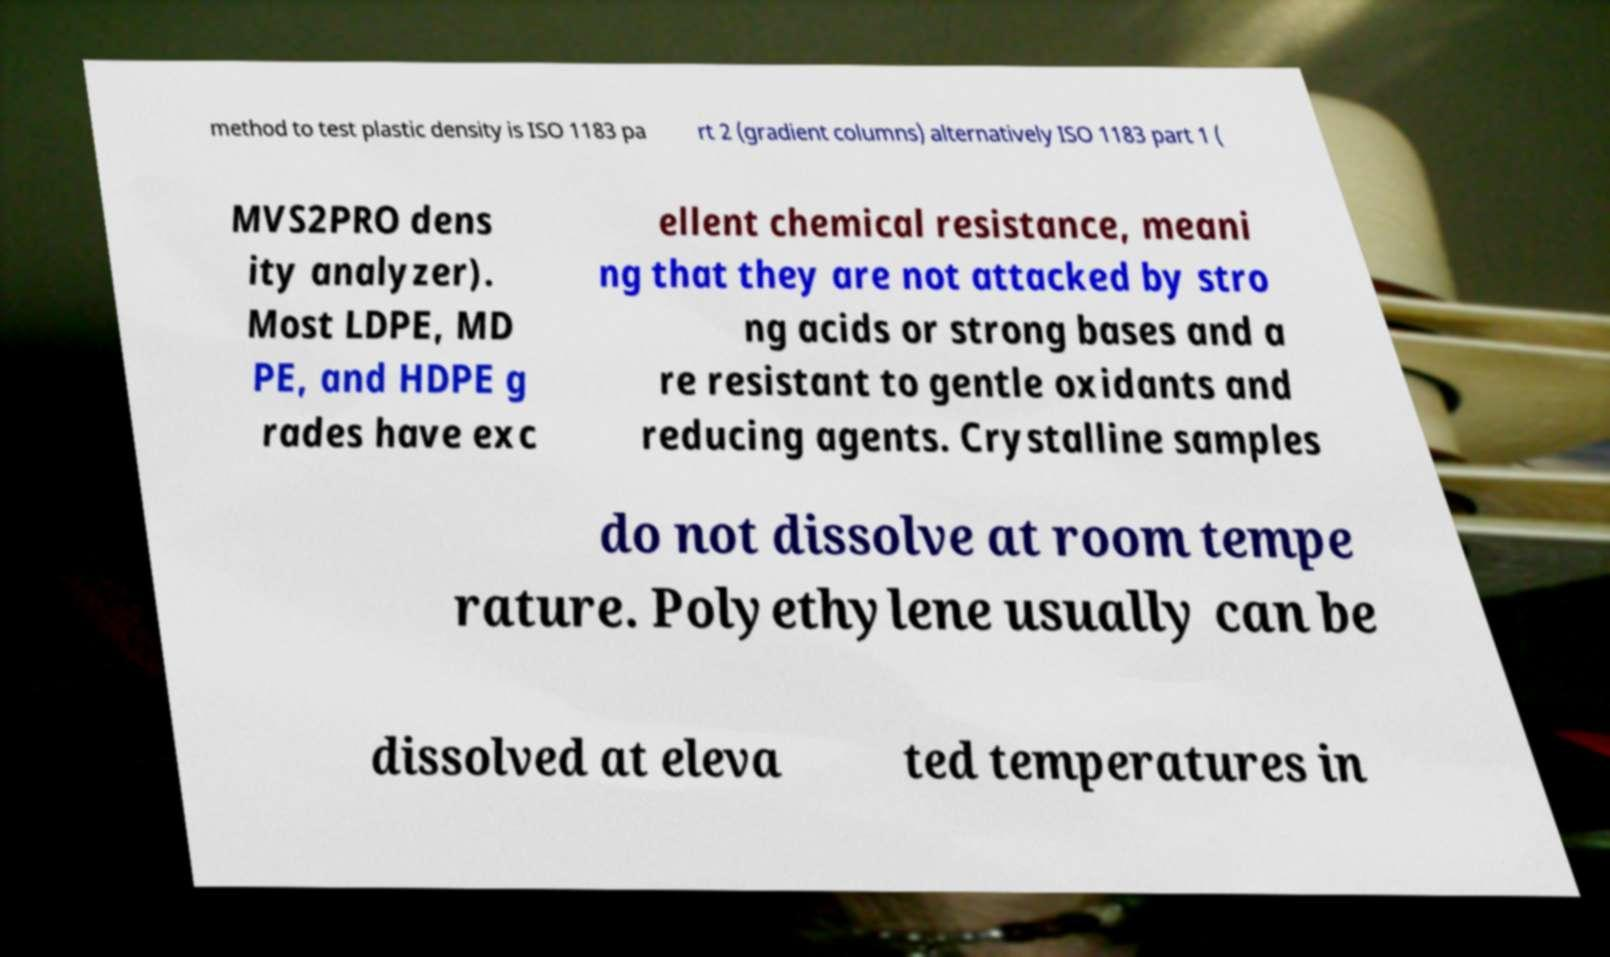What messages or text are displayed in this image? I need them in a readable, typed format. method to test plastic density is ISO 1183 pa rt 2 (gradient columns) alternatively ISO 1183 part 1 ( MVS2PRO dens ity analyzer). Most LDPE, MD PE, and HDPE g rades have exc ellent chemical resistance, meani ng that they are not attacked by stro ng acids or strong bases and a re resistant to gentle oxidants and reducing agents. Crystalline samples do not dissolve at room tempe rature. Polyethylene usually can be dissolved at eleva ted temperatures in 